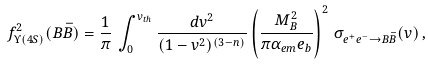Convert formula to latex. <formula><loc_0><loc_0><loc_500><loc_500>f _ { \Upsilon ( 4 S ) } ^ { 2 } ( B \bar { B } ) = \frac { 1 } { \pi } \, \int _ { 0 } ^ { v _ { t h } } \frac { d v ^ { 2 } } { ( 1 - v ^ { 2 } ) ^ { ( 3 - n ) } } \left ( \frac { M _ { B } ^ { 2 } } { \pi \alpha _ { e m } e _ { b } } \right ) ^ { 2 } \, \sigma _ { e ^ { + } e ^ { - } \to B \bar { B } } ( v ) \, ,</formula> 